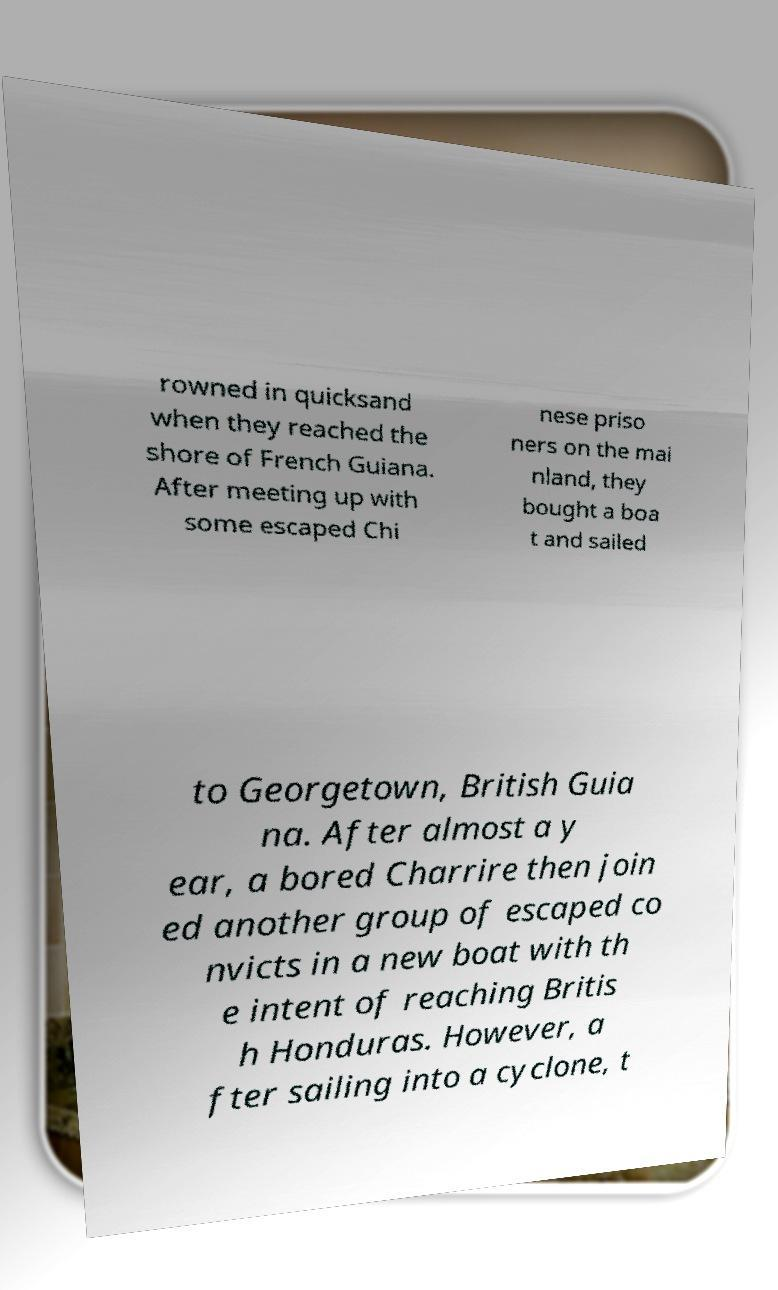What messages or text are displayed in this image? I need them in a readable, typed format. rowned in quicksand when they reached the shore of French Guiana. After meeting up with some escaped Chi nese priso ners on the mai nland, they bought a boa t and sailed to Georgetown, British Guia na. After almost a y ear, a bored Charrire then join ed another group of escaped co nvicts in a new boat with th e intent of reaching Britis h Honduras. However, a fter sailing into a cyclone, t 